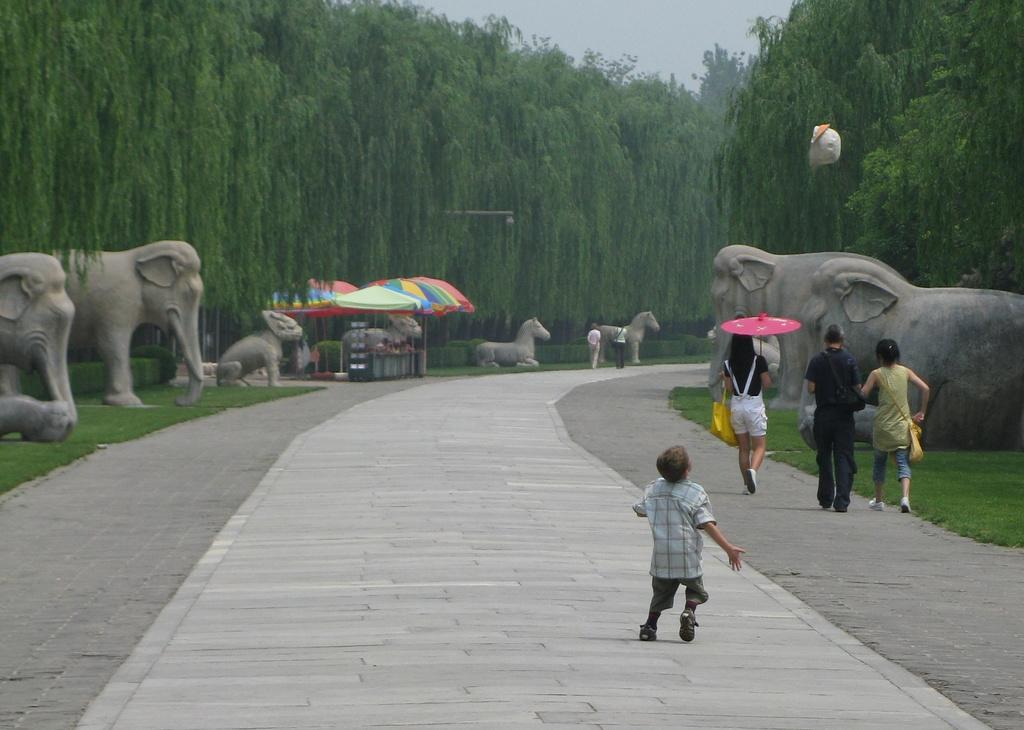How many people are in the group visible in the image? There is a group of people standing in the image, but the exact number is not specified. What is one person in the group holding? One person in the group is holding an umbrella in the image. What type of animals can be seen in the background of the image? There are sculptures of elephants and horses in the background of the image. What else can be seen in the background of the image? There are umbrellas, trees, a stall, and the sky visible in the background of the image. What type of gun is the spy using to protect the maid in the image? There is no gun, spy, or maid present in the image. 